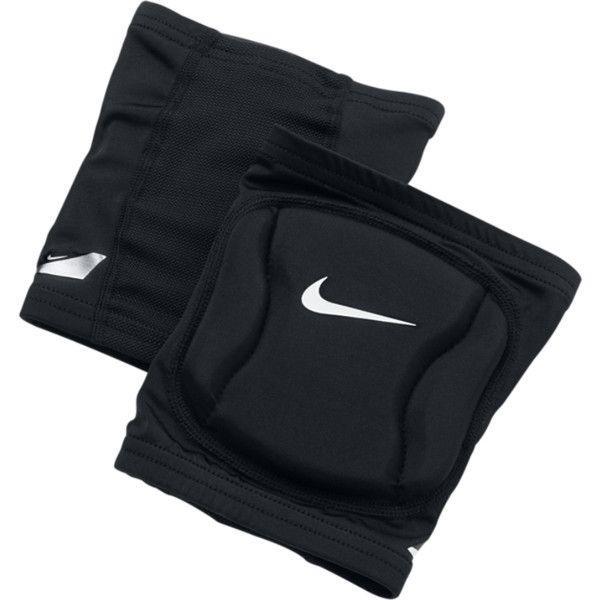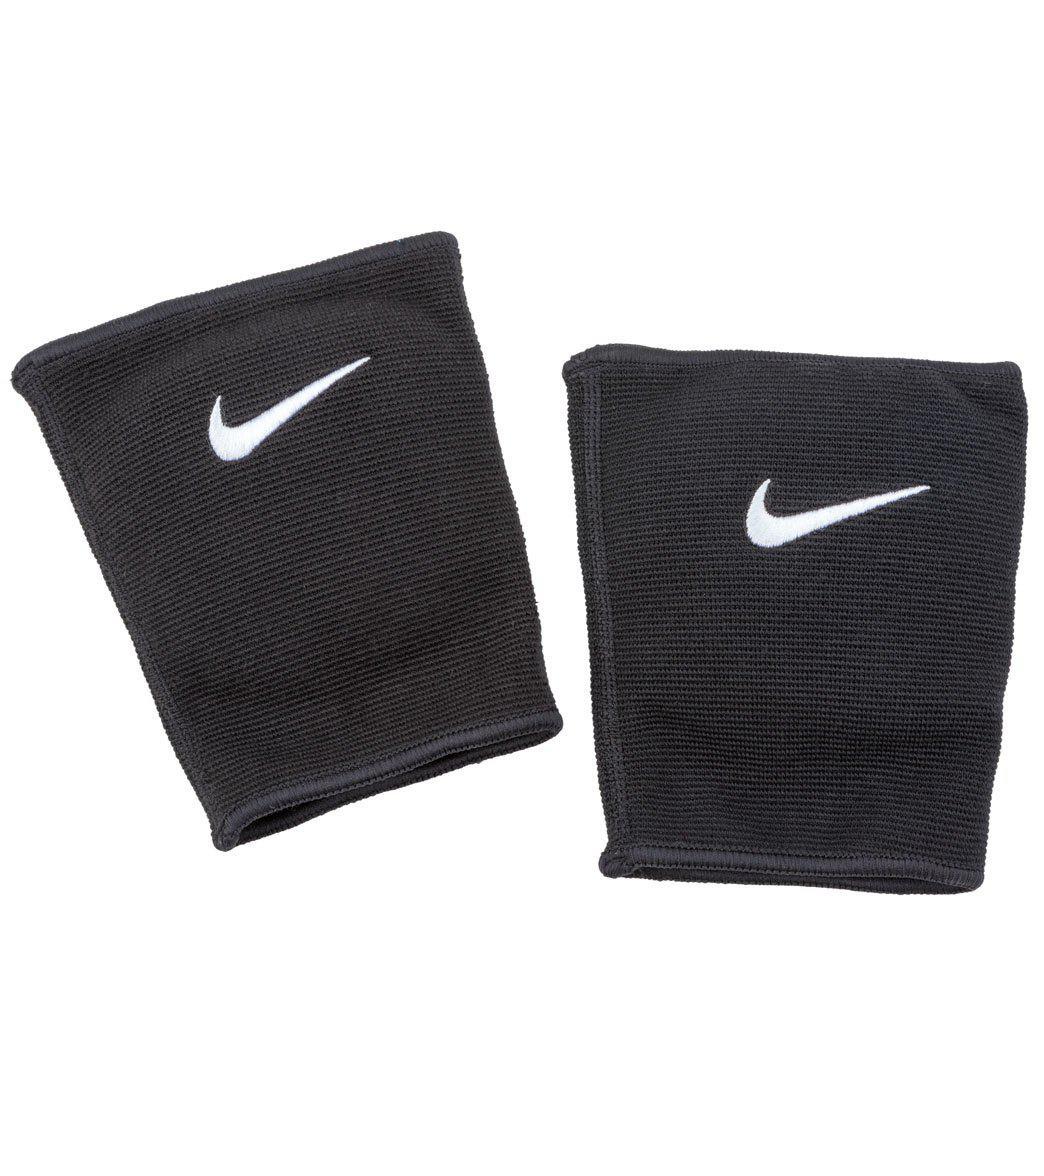The first image is the image on the left, the second image is the image on the right. Analyze the images presented: Is the assertion "Each image shows a pair of knee wraps." valid? Answer yes or no. Yes. 